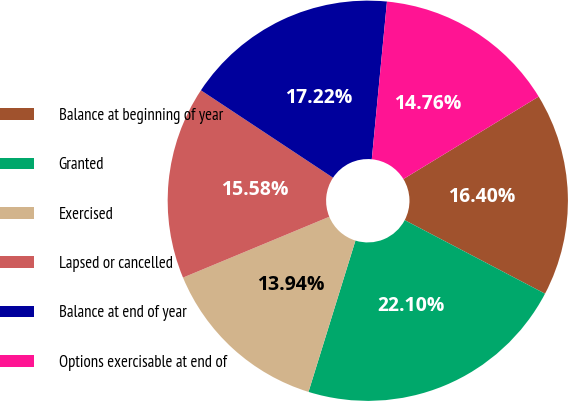Convert chart to OTSL. <chart><loc_0><loc_0><loc_500><loc_500><pie_chart><fcel>Balance at beginning of year<fcel>Granted<fcel>Exercised<fcel>Lapsed or cancelled<fcel>Balance at end of year<fcel>Options exercisable at end of<nl><fcel>16.4%<fcel>22.1%<fcel>13.94%<fcel>15.58%<fcel>17.22%<fcel>14.76%<nl></chart> 